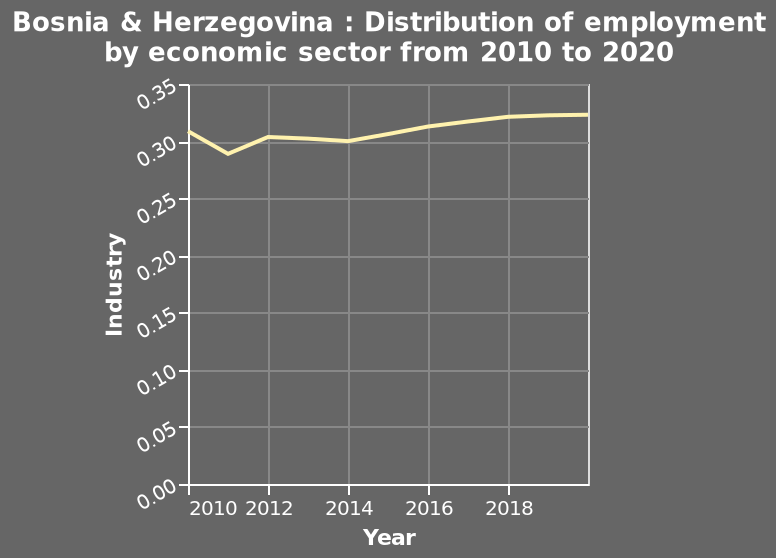<image>
What does the x-axis represent in the area diagram? The x-axis represents the years from 2010 to 2018 on a linear scale. How has the employment distribution in the industry changed overall between 2010 and 2018? It has slightly increased. 